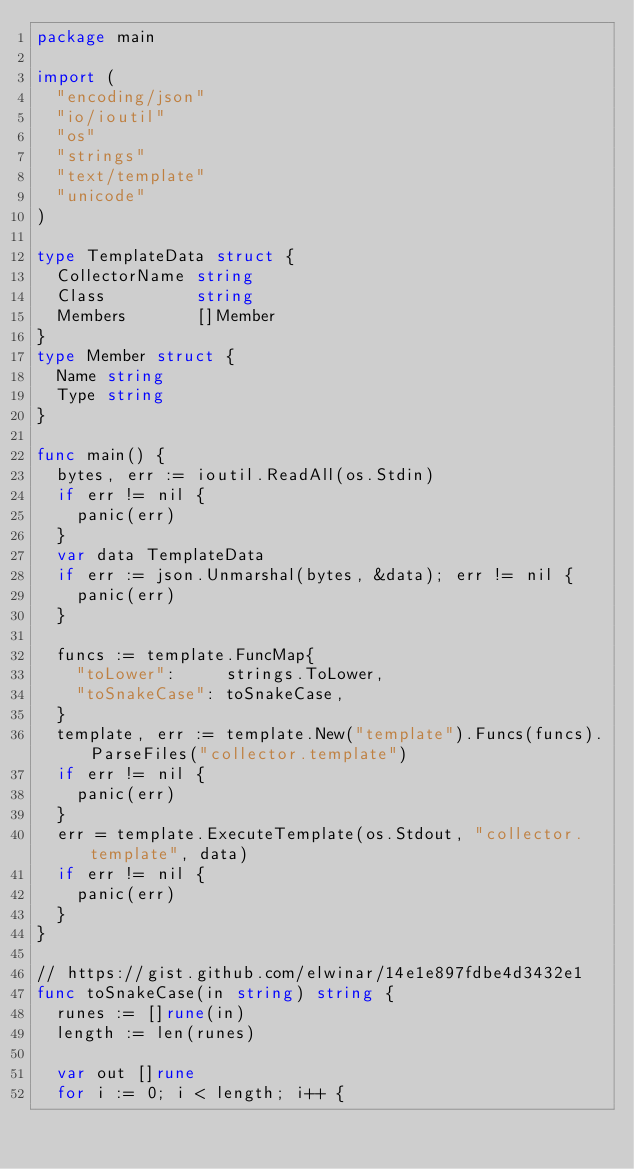<code> <loc_0><loc_0><loc_500><loc_500><_Go_>package main

import (
	"encoding/json"
	"io/ioutil"
	"os"
	"strings"
	"text/template"
	"unicode"
)

type TemplateData struct {
	CollectorName string
	Class         string
	Members       []Member
}
type Member struct {
	Name string
	Type string
}

func main() {
	bytes, err := ioutil.ReadAll(os.Stdin)
	if err != nil {
		panic(err)
	}
	var data TemplateData
	if err := json.Unmarshal(bytes, &data); err != nil {
		panic(err)
	}

	funcs := template.FuncMap{
		"toLower":     strings.ToLower,
		"toSnakeCase": toSnakeCase,
	}
	template, err := template.New("template").Funcs(funcs).ParseFiles("collector.template")
	if err != nil {
		panic(err)
	}
	err = template.ExecuteTemplate(os.Stdout, "collector.template", data)
	if err != nil {
		panic(err)
	}
}

// https://gist.github.com/elwinar/14e1e897fdbe4d3432e1
func toSnakeCase(in string) string {
	runes := []rune(in)
	length := len(runes)

	var out []rune
	for i := 0; i < length; i++ {</code> 